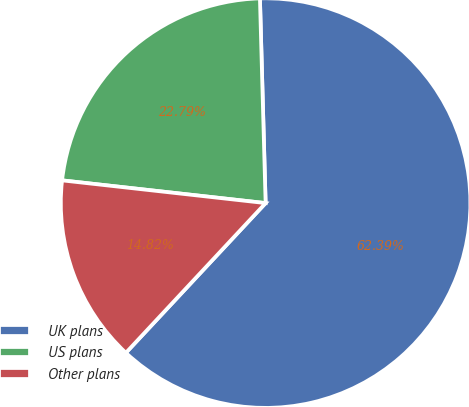<chart> <loc_0><loc_0><loc_500><loc_500><pie_chart><fcel>UK plans<fcel>US plans<fcel>Other plans<nl><fcel>62.4%<fcel>22.79%<fcel>14.82%<nl></chart> 